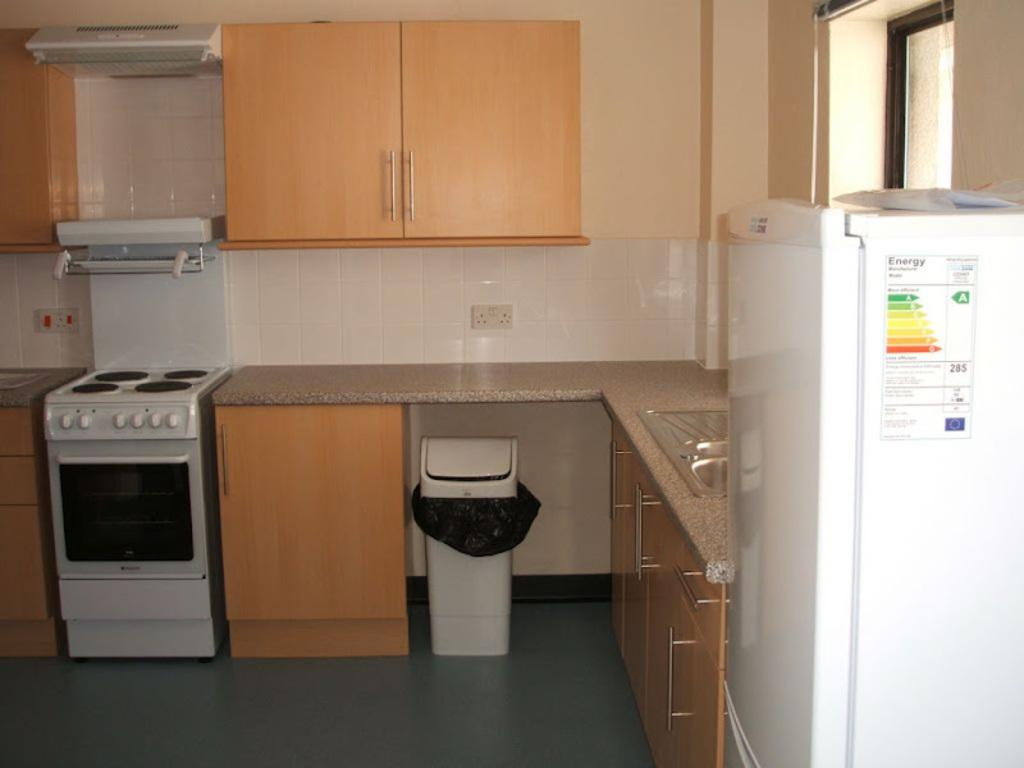<image>
Provide a brief description of the given image. The white fridge in the kitchen has energy information on its side. 